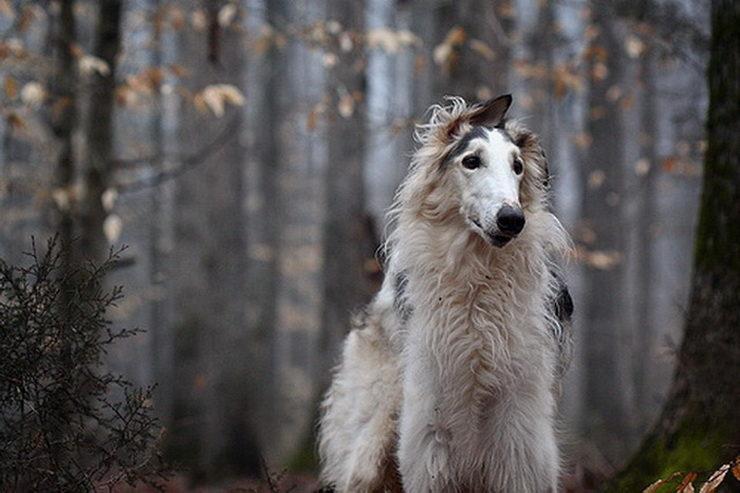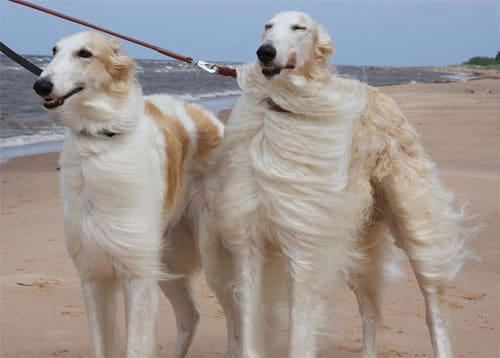The first image is the image on the left, the second image is the image on the right. Evaluate the accuracy of this statement regarding the images: "The dog in the left image is standing on the sidewalk.". Is it true? Answer yes or no. No. The first image is the image on the left, the second image is the image on the right. Evaluate the accuracy of this statement regarding the images: "A dog is standing in a field in the image on the right.". Is it true? Answer yes or no. No. 